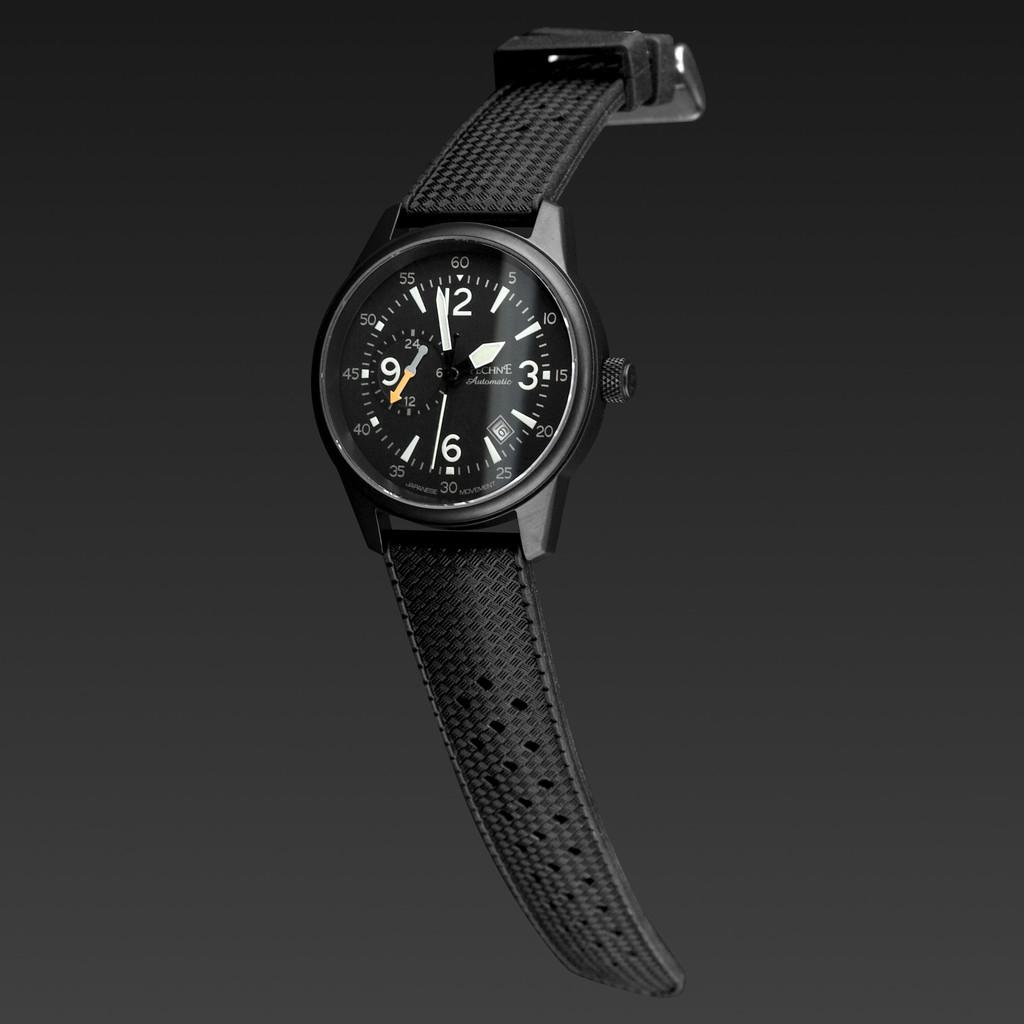<image>
Summarize the visual content of the image. A watch made by Pechne says that today is the 16th. 